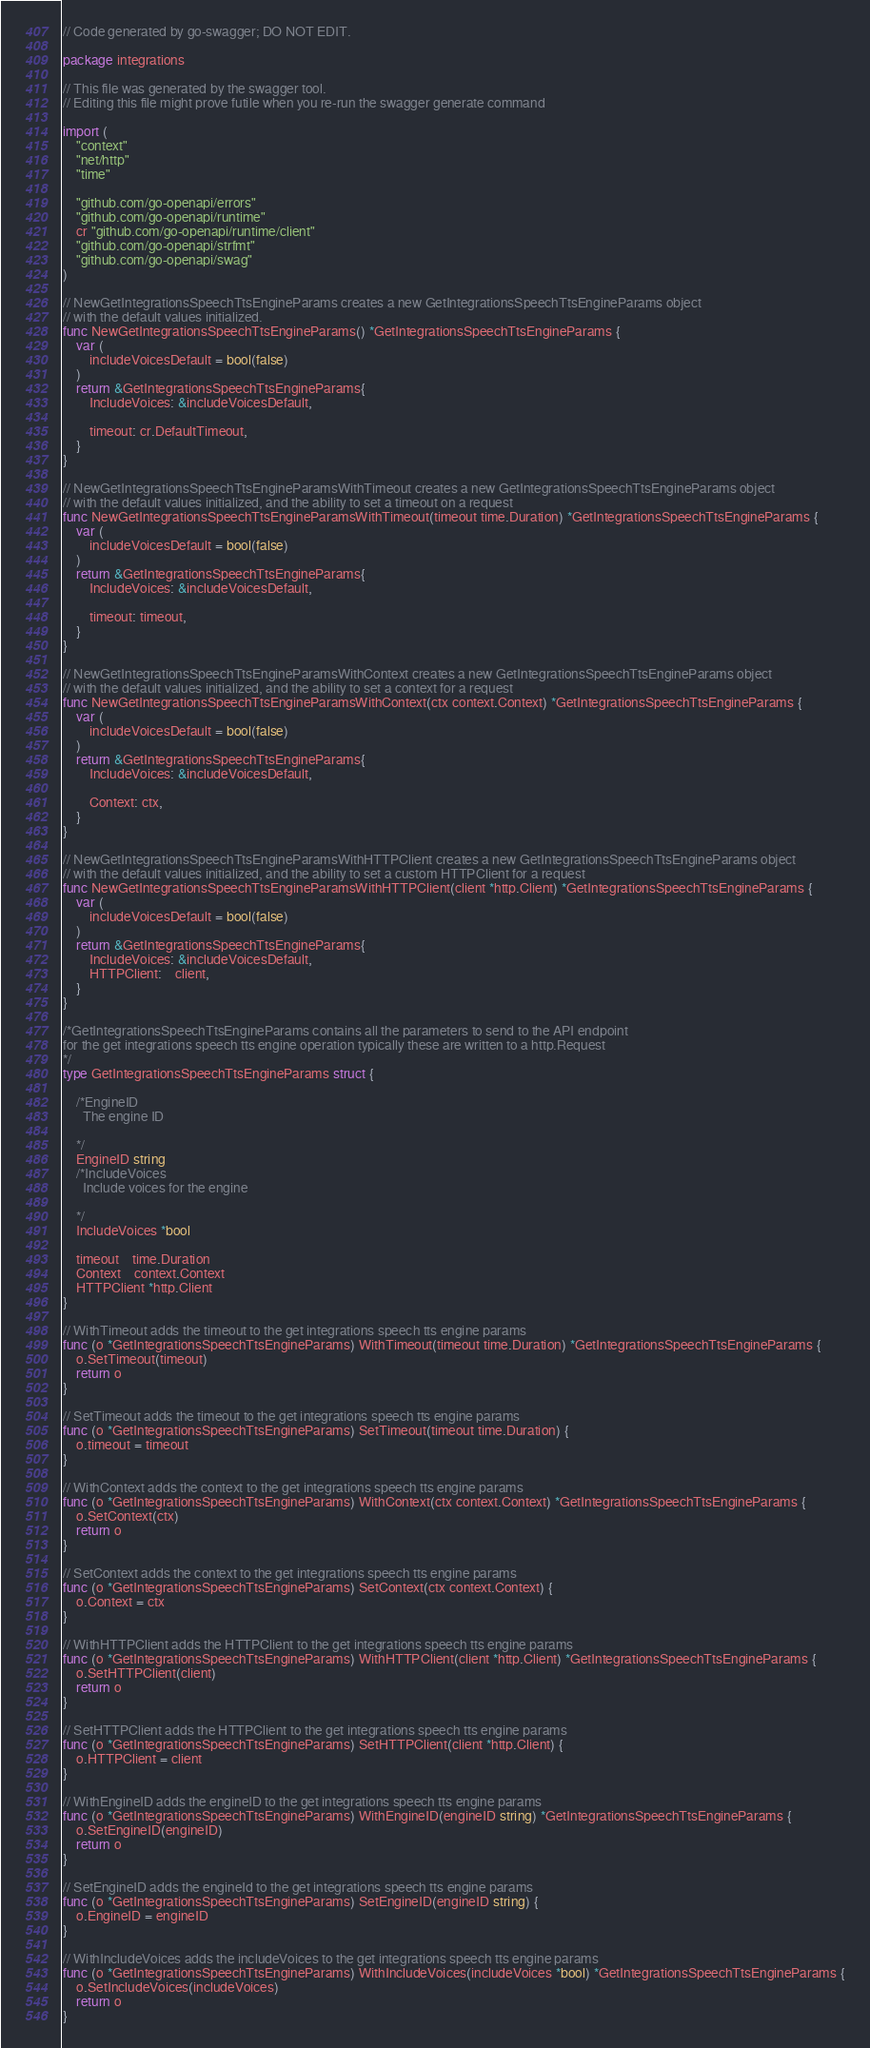Convert code to text. <code><loc_0><loc_0><loc_500><loc_500><_Go_>// Code generated by go-swagger; DO NOT EDIT.

package integrations

// This file was generated by the swagger tool.
// Editing this file might prove futile when you re-run the swagger generate command

import (
	"context"
	"net/http"
	"time"

	"github.com/go-openapi/errors"
	"github.com/go-openapi/runtime"
	cr "github.com/go-openapi/runtime/client"
	"github.com/go-openapi/strfmt"
	"github.com/go-openapi/swag"
)

// NewGetIntegrationsSpeechTtsEngineParams creates a new GetIntegrationsSpeechTtsEngineParams object
// with the default values initialized.
func NewGetIntegrationsSpeechTtsEngineParams() *GetIntegrationsSpeechTtsEngineParams {
	var (
		includeVoicesDefault = bool(false)
	)
	return &GetIntegrationsSpeechTtsEngineParams{
		IncludeVoices: &includeVoicesDefault,

		timeout: cr.DefaultTimeout,
	}
}

// NewGetIntegrationsSpeechTtsEngineParamsWithTimeout creates a new GetIntegrationsSpeechTtsEngineParams object
// with the default values initialized, and the ability to set a timeout on a request
func NewGetIntegrationsSpeechTtsEngineParamsWithTimeout(timeout time.Duration) *GetIntegrationsSpeechTtsEngineParams {
	var (
		includeVoicesDefault = bool(false)
	)
	return &GetIntegrationsSpeechTtsEngineParams{
		IncludeVoices: &includeVoicesDefault,

		timeout: timeout,
	}
}

// NewGetIntegrationsSpeechTtsEngineParamsWithContext creates a new GetIntegrationsSpeechTtsEngineParams object
// with the default values initialized, and the ability to set a context for a request
func NewGetIntegrationsSpeechTtsEngineParamsWithContext(ctx context.Context) *GetIntegrationsSpeechTtsEngineParams {
	var (
		includeVoicesDefault = bool(false)
	)
	return &GetIntegrationsSpeechTtsEngineParams{
		IncludeVoices: &includeVoicesDefault,

		Context: ctx,
	}
}

// NewGetIntegrationsSpeechTtsEngineParamsWithHTTPClient creates a new GetIntegrationsSpeechTtsEngineParams object
// with the default values initialized, and the ability to set a custom HTTPClient for a request
func NewGetIntegrationsSpeechTtsEngineParamsWithHTTPClient(client *http.Client) *GetIntegrationsSpeechTtsEngineParams {
	var (
		includeVoicesDefault = bool(false)
	)
	return &GetIntegrationsSpeechTtsEngineParams{
		IncludeVoices: &includeVoicesDefault,
		HTTPClient:    client,
	}
}

/*GetIntegrationsSpeechTtsEngineParams contains all the parameters to send to the API endpoint
for the get integrations speech tts engine operation typically these are written to a http.Request
*/
type GetIntegrationsSpeechTtsEngineParams struct {

	/*EngineID
	  The engine ID

	*/
	EngineID string
	/*IncludeVoices
	  Include voices for the engine

	*/
	IncludeVoices *bool

	timeout    time.Duration
	Context    context.Context
	HTTPClient *http.Client
}

// WithTimeout adds the timeout to the get integrations speech tts engine params
func (o *GetIntegrationsSpeechTtsEngineParams) WithTimeout(timeout time.Duration) *GetIntegrationsSpeechTtsEngineParams {
	o.SetTimeout(timeout)
	return o
}

// SetTimeout adds the timeout to the get integrations speech tts engine params
func (o *GetIntegrationsSpeechTtsEngineParams) SetTimeout(timeout time.Duration) {
	o.timeout = timeout
}

// WithContext adds the context to the get integrations speech tts engine params
func (o *GetIntegrationsSpeechTtsEngineParams) WithContext(ctx context.Context) *GetIntegrationsSpeechTtsEngineParams {
	o.SetContext(ctx)
	return o
}

// SetContext adds the context to the get integrations speech tts engine params
func (o *GetIntegrationsSpeechTtsEngineParams) SetContext(ctx context.Context) {
	o.Context = ctx
}

// WithHTTPClient adds the HTTPClient to the get integrations speech tts engine params
func (o *GetIntegrationsSpeechTtsEngineParams) WithHTTPClient(client *http.Client) *GetIntegrationsSpeechTtsEngineParams {
	o.SetHTTPClient(client)
	return o
}

// SetHTTPClient adds the HTTPClient to the get integrations speech tts engine params
func (o *GetIntegrationsSpeechTtsEngineParams) SetHTTPClient(client *http.Client) {
	o.HTTPClient = client
}

// WithEngineID adds the engineID to the get integrations speech tts engine params
func (o *GetIntegrationsSpeechTtsEngineParams) WithEngineID(engineID string) *GetIntegrationsSpeechTtsEngineParams {
	o.SetEngineID(engineID)
	return o
}

// SetEngineID adds the engineId to the get integrations speech tts engine params
func (o *GetIntegrationsSpeechTtsEngineParams) SetEngineID(engineID string) {
	o.EngineID = engineID
}

// WithIncludeVoices adds the includeVoices to the get integrations speech tts engine params
func (o *GetIntegrationsSpeechTtsEngineParams) WithIncludeVoices(includeVoices *bool) *GetIntegrationsSpeechTtsEngineParams {
	o.SetIncludeVoices(includeVoices)
	return o
}
</code> 